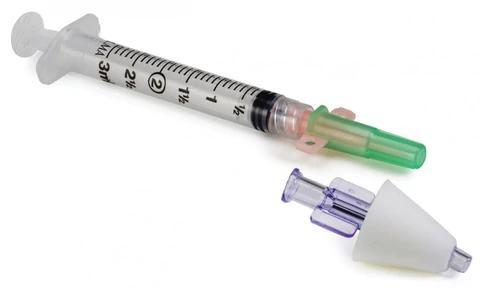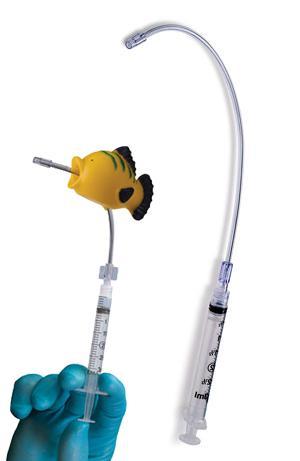The first image is the image on the left, the second image is the image on the right. For the images shown, is this caption "The image on the right contains a cone." true? Answer yes or no. No. 